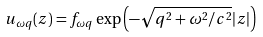Convert formula to latex. <formula><loc_0><loc_0><loc_500><loc_500>u _ { \omega q } ( z ) = f _ { \omega q } \exp \left ( - \sqrt { q ^ { 2 } + \omega ^ { 2 } / c ^ { 2 } } | z | \right )</formula> 